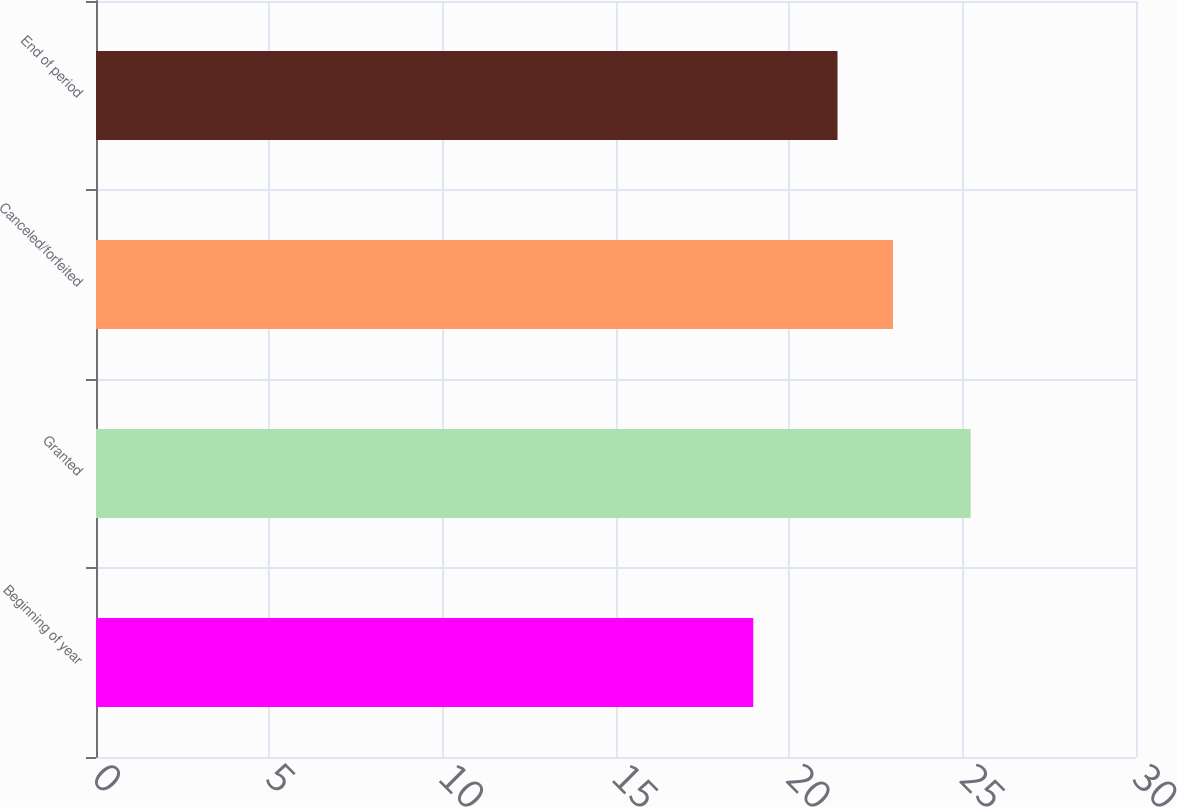Convert chart. <chart><loc_0><loc_0><loc_500><loc_500><bar_chart><fcel>Beginning of year<fcel>Granted<fcel>Canceled/forfeited<fcel>End of period<nl><fcel>18.96<fcel>25.23<fcel>22.99<fcel>21.39<nl></chart> 